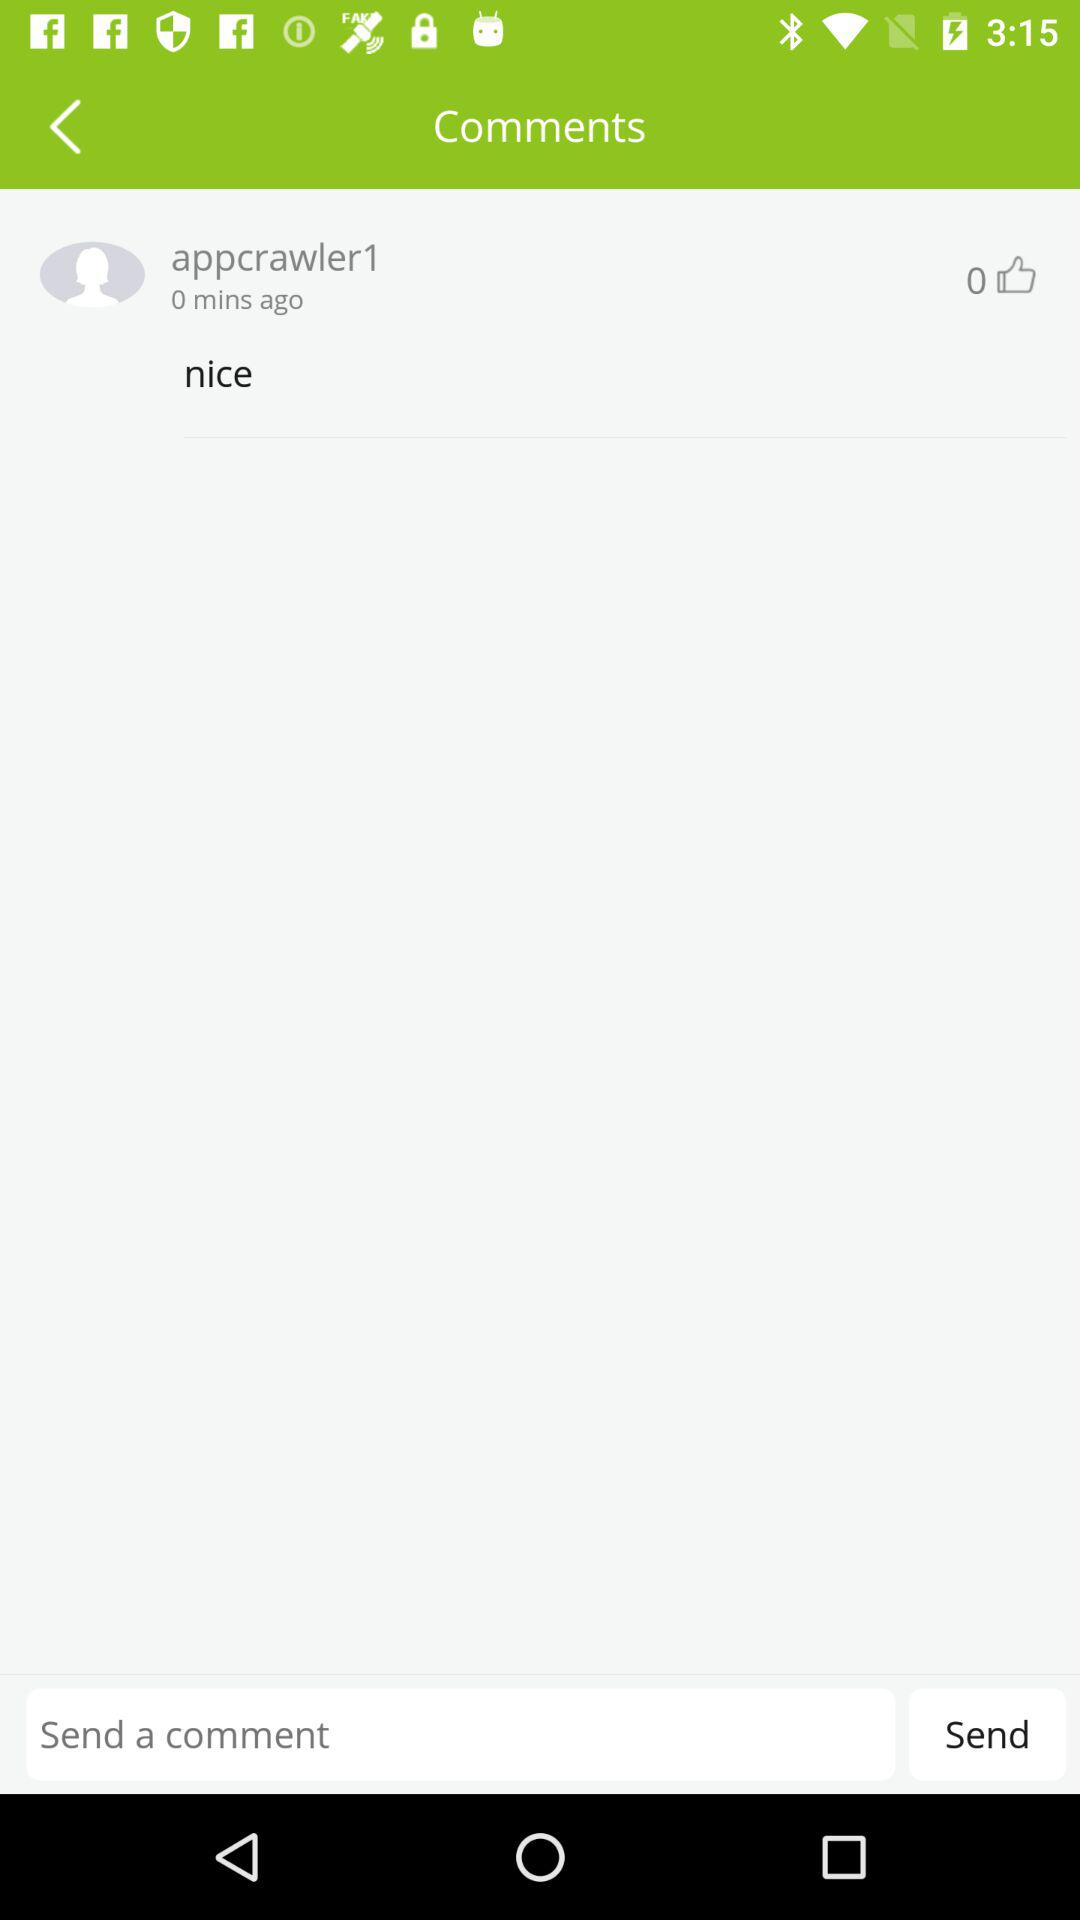How many likes are there on the comment? There are 0 likes on the comment. 